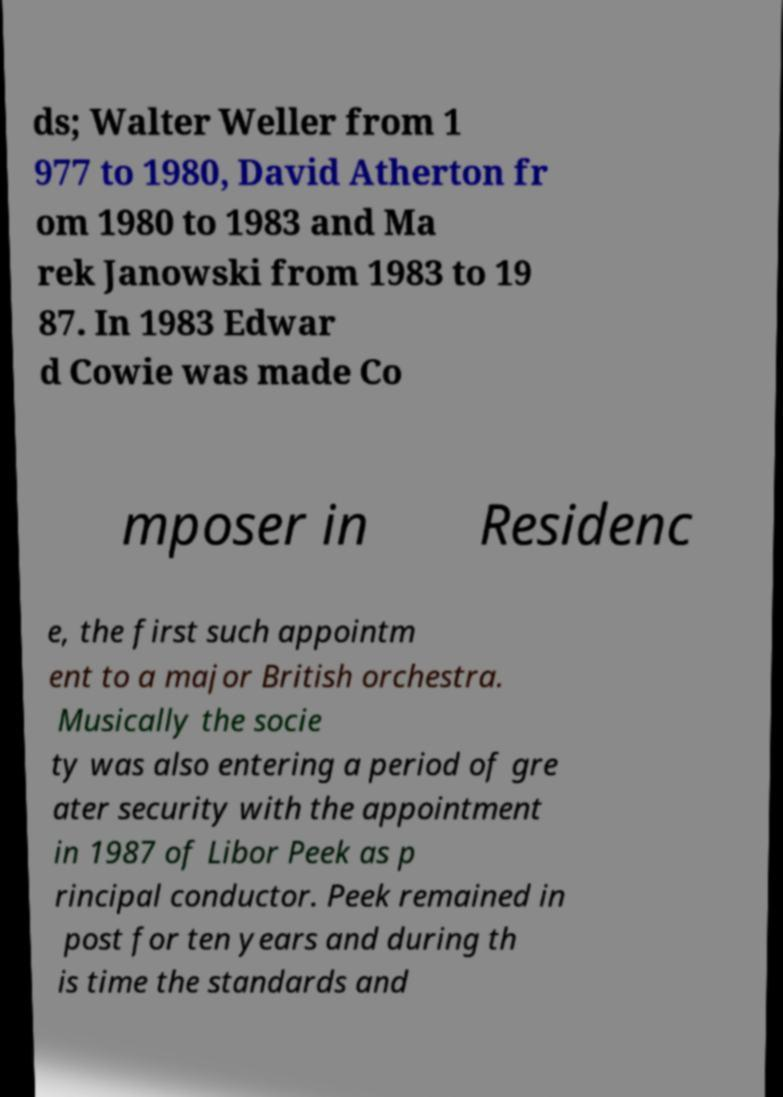What messages or text are displayed in this image? I need them in a readable, typed format. ds; Walter Weller from 1 977 to 1980, David Atherton fr om 1980 to 1983 and Ma rek Janowski from 1983 to 19 87. In 1983 Edwar d Cowie was made Co mposer in Residenc e, the first such appointm ent to a major British orchestra. Musically the socie ty was also entering a period of gre ater security with the appointment in 1987 of Libor Peek as p rincipal conductor. Peek remained in post for ten years and during th is time the standards and 